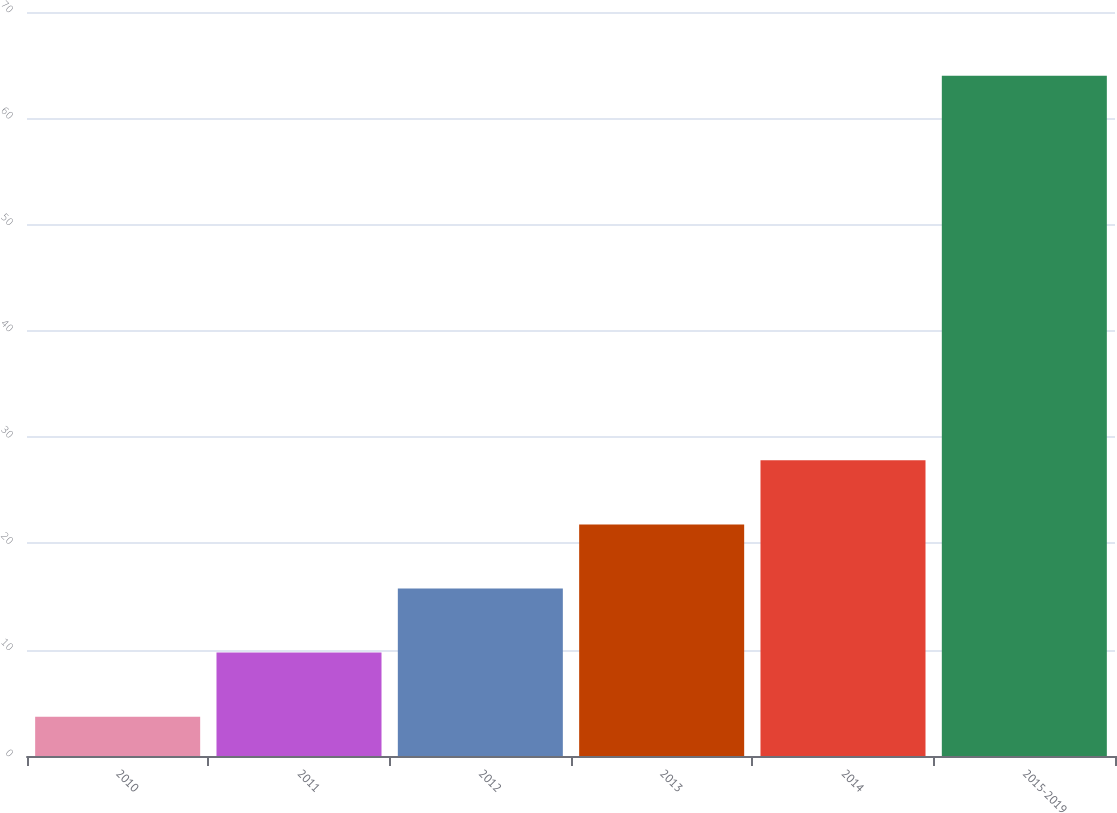Convert chart. <chart><loc_0><loc_0><loc_500><loc_500><bar_chart><fcel>2010<fcel>2011<fcel>2012<fcel>2013<fcel>2014<fcel>2015-2019<nl><fcel>3.7<fcel>9.73<fcel>15.76<fcel>21.79<fcel>27.82<fcel>64<nl></chart> 